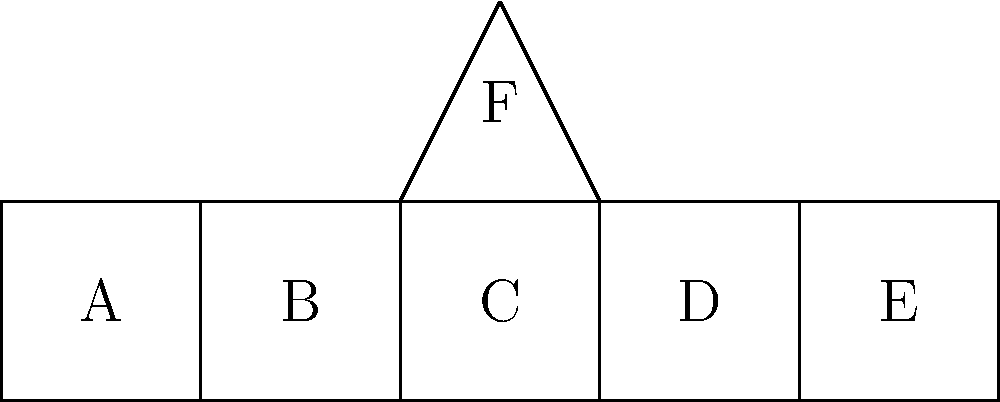Which of the following represents the correct unfolded shape of a traditional Turkish tea kettle (çaydanlık) that you might have used in your village home in Dedebeyli? The labels A, B, C, D, E, and F represent different parts of the unfolded kettle. To identify the correct unfolded shape of a traditional Turkish tea kettle, let's consider its components:

1. The base (A): This is the bottom of the kettle, typically circular or slightly oval.
2. The sides (B, C, D, E): These form the walls of the kettle when folded.
3. The top (F): This is the conical or dome-shaped lid of the kettle.

Step-by-step analysis:
1. The base (A) is correct as it forms the bottom of the kettle.
2. The sides (B, C, D, E) are connected to each other and to the base, forming a continuous surface when folded.
3. The top (F) is triangular, which will form a conical shape when folded, typical of traditional Turkish tea kettles.
4. The arrangement of the parts is logical: the base is central, with sides extending from it, and the top piece positioned to form the lid.

This unfolded shape, when folded properly, would create a cylindrical body with a conical top, matching the typical shape of a traditional Turkish tea kettle used in villages like Dedebeyli.
Answer: The given unfolded shape is correct for a traditional Turkish tea kettle. 